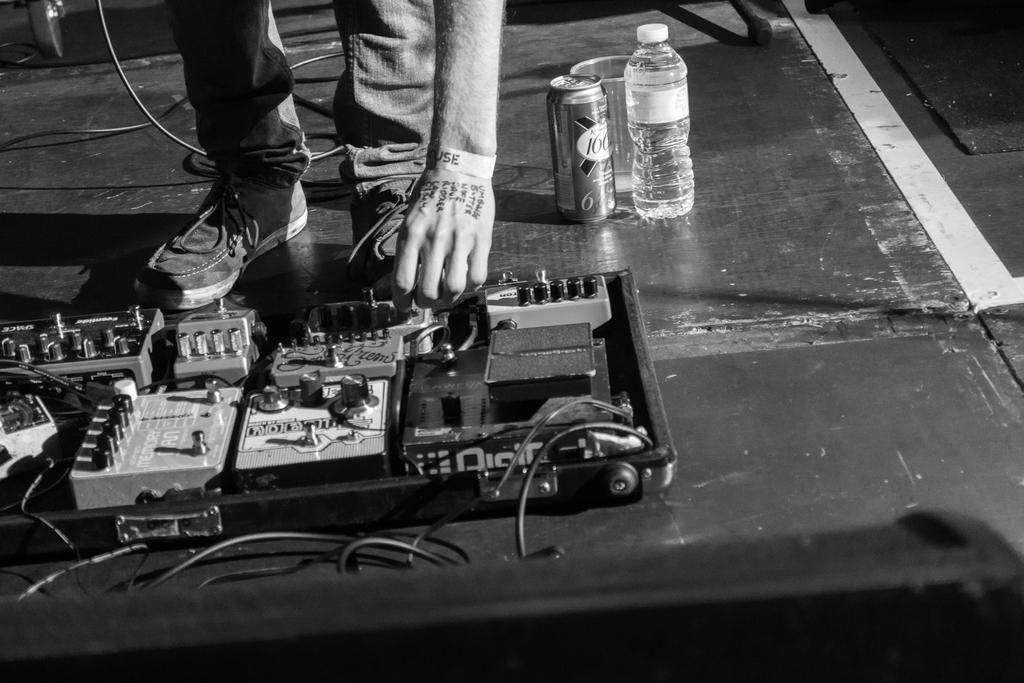What is the color scheme of the image? The image is black and white. What body parts of a person can be seen in the image? There are legs and a hand of a person in the image. What objects are present in the image? There is a bottle, a tin, and electrical objects on the surface in the image. Where is the library located in the image? There is no library present in the image. Can you hear a whistle in the image? There is no sound, including a whistle, present in the image. 